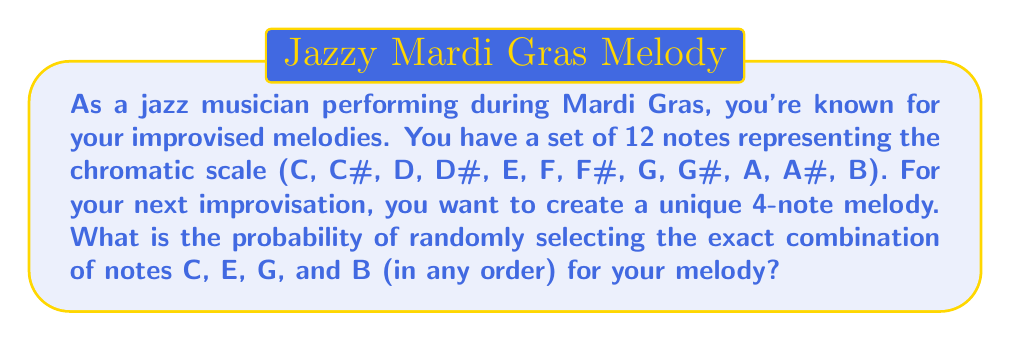Give your solution to this math problem. Let's approach this step-by-step:

1) First, we need to calculate the total number of possible 4-note combinations from 12 notes. This is a combination problem, as the order doesn't matter. We use the formula:

   $${12 \choose 4} = \frac{12!}{4!(12-4)!} = \frac{12!}{4!8!}$$

2) Calculating this:
   $$\frac{12 \cdot 11 \cdot 10 \cdot 9}{4 \cdot 3 \cdot 2 \cdot 1} = 495$$

3) Now, we only have one favorable outcome: the combination of C, E, G, and B. The order doesn't matter, so this is just one combination.

4) The probability is therefore:

   $$P(\text{C, E, G, B}) = \frac{\text{favorable outcomes}}{\text{total outcomes}} = \frac{1}{495}$$
Answer: The probability of randomly selecting the exact combination of notes C, E, G, and B (in any order) is $\frac{1}{495}$ or approximately 0.00202 or 0.202%. 